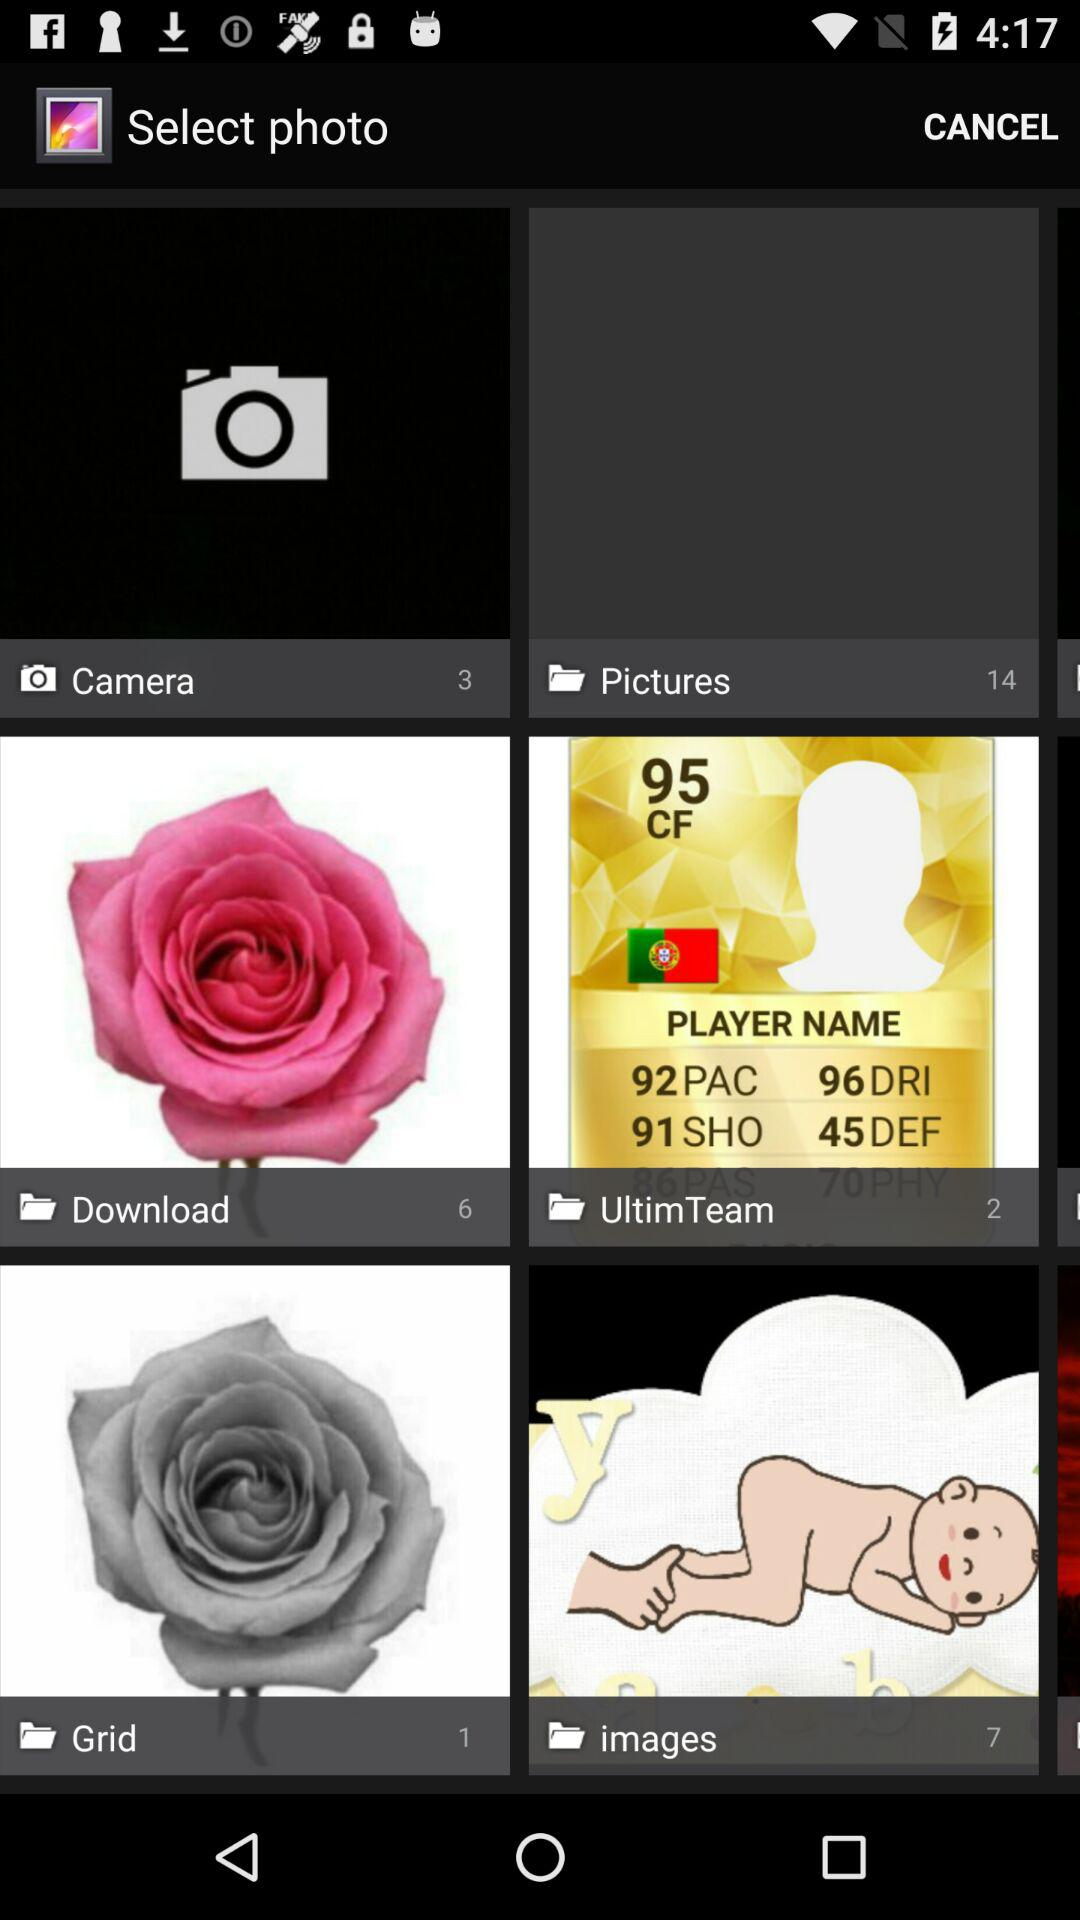How many photos are in the "Pictures" folder? There are 14 photos in the "Pictures" folder. 